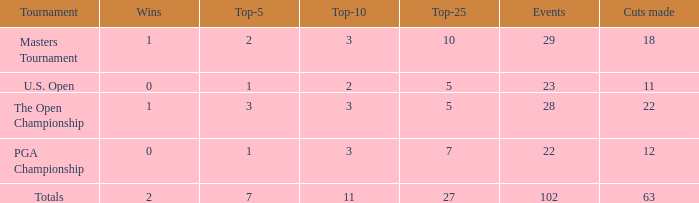How many vuts does a player have if they have achieved 2 wins and no more than 6 top 5 finishes? None. 